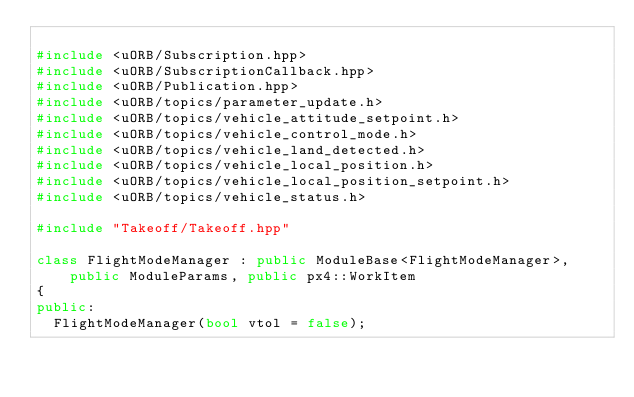Convert code to text. <code><loc_0><loc_0><loc_500><loc_500><_C++_>
#include <uORB/Subscription.hpp>
#include <uORB/SubscriptionCallback.hpp>
#include <uORB/Publication.hpp>
#include <uORB/topics/parameter_update.h>
#include <uORB/topics/vehicle_attitude_setpoint.h>
#include <uORB/topics/vehicle_control_mode.h>
#include <uORB/topics/vehicle_land_detected.h>
#include <uORB/topics/vehicle_local_position.h>
#include <uORB/topics/vehicle_local_position_setpoint.h>
#include <uORB/topics/vehicle_status.h>

#include "Takeoff/Takeoff.hpp"

class FlightModeManager : public ModuleBase<FlightModeManager>, public ModuleParams, public px4::WorkItem
{
public:
	FlightModeManager(bool vtol = false);</code> 